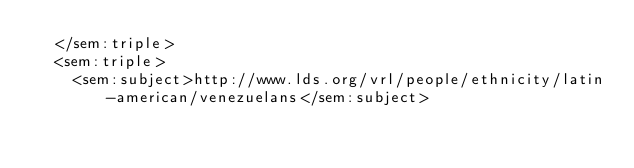<code> <loc_0><loc_0><loc_500><loc_500><_XML_>  </sem:triple>
  <sem:triple>
    <sem:subject>http://www.lds.org/vrl/people/ethnicity/latin-american/venezuelans</sem:subject></code> 